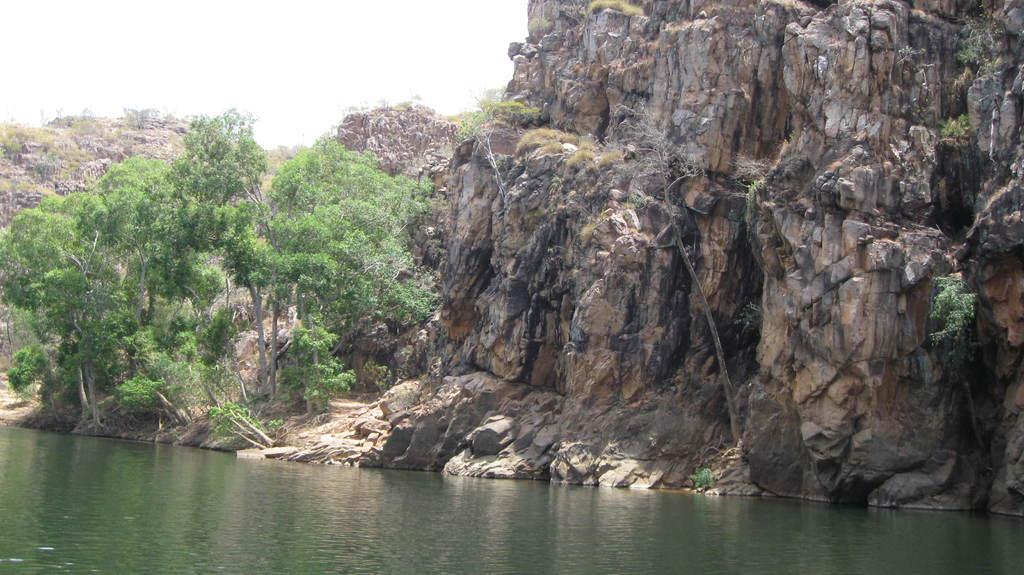Could you give a brief overview of what you see in this image? This image consists of water at the bottom. There are trees on the left side. There is sky at the top. 